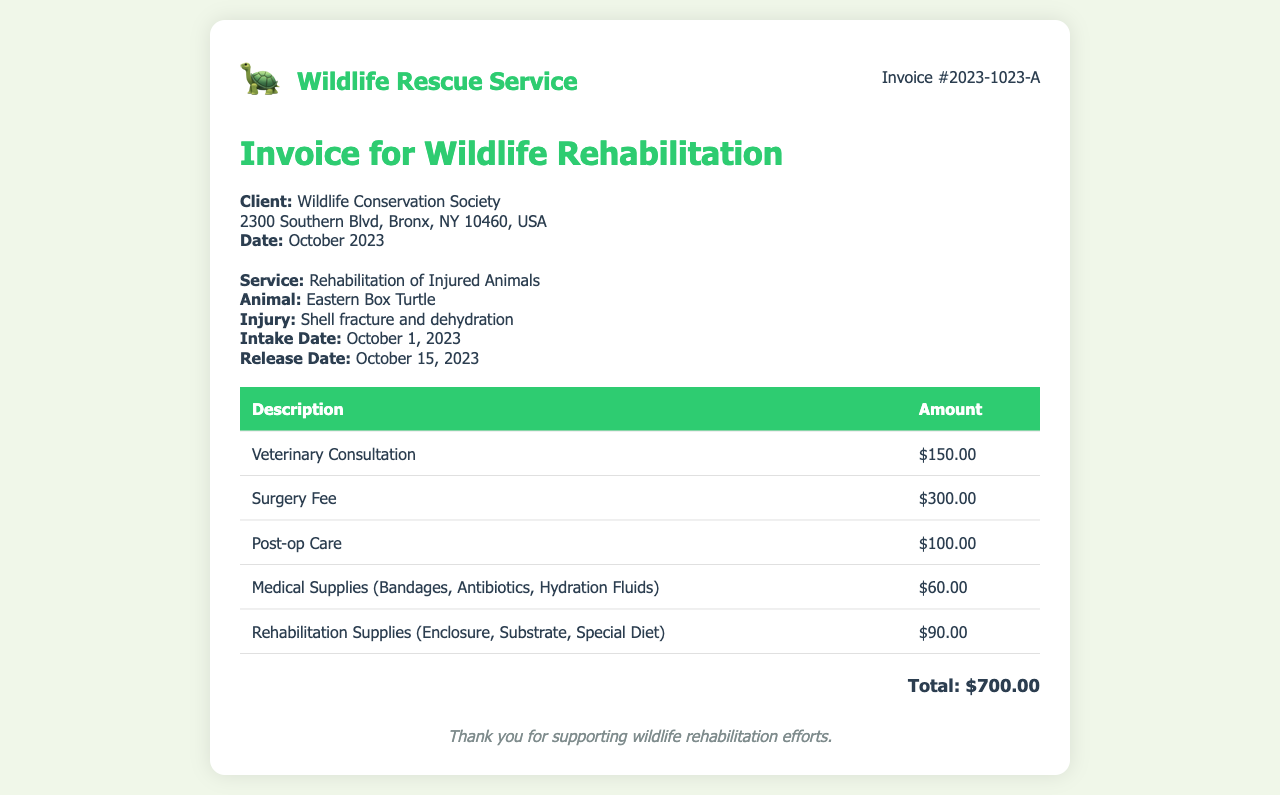what is the logo of the invoice? The logo of the invoice features an icon of a turtle, represented by the emoji 🐢.
Answer: Wildlife Rescue Service who is the client? The invoice indicates the client as the Wildlife Conservation Society.
Answer: Wildlife Conservation Society what is the total amount for the services rendered? The total amount for the services rendered is provided at the end of the invoice.
Answer: $700.00 when was the animal admitted for rehabilitation? The intake date for the rehabilitation of the injured animal is specified in the document.
Answer: October 1, 2023 what injury did the Eastern Box Turtle sustain? The document details the specific injury that the Eastern Box Turtle had.
Answer: Shell fracture and dehydration how much was charged for the surgery fee? The invoice lists the surgery fee as one of the charges.
Answer: $300.00 how many days did the turtle stay in rehabilitation? The document provides the intake and release dates, which allows for calculating the duration of stay.
Answer: 14 days what types of supplies were included in the medical expenses? The invoice outlines the kinds of supplies categorized under medical supplies used during rehabilitation.
Answer: Bandages, Antibiotics, Hydration Fluids when was the animal released? The release date for the Eastern Box Turtle is specified in the service details section.
Answer: October 15, 2023 